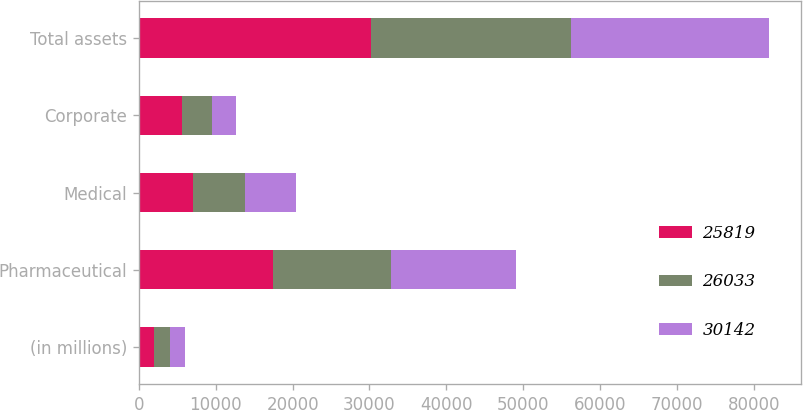Convert chart to OTSL. <chart><loc_0><loc_0><loc_500><loc_500><stacked_bar_chart><ecel><fcel>(in millions)<fcel>Pharmaceutical<fcel>Medical<fcel>Corporate<fcel>Total assets<nl><fcel>25819<fcel>2015<fcel>17385<fcel>7095<fcel>5662<fcel>30142<nl><fcel>26033<fcel>2014<fcel>15361<fcel>6768<fcel>3904<fcel>26033<nl><fcel>30142<fcel>2013<fcel>16258<fcel>6521<fcel>3040<fcel>25819<nl></chart> 